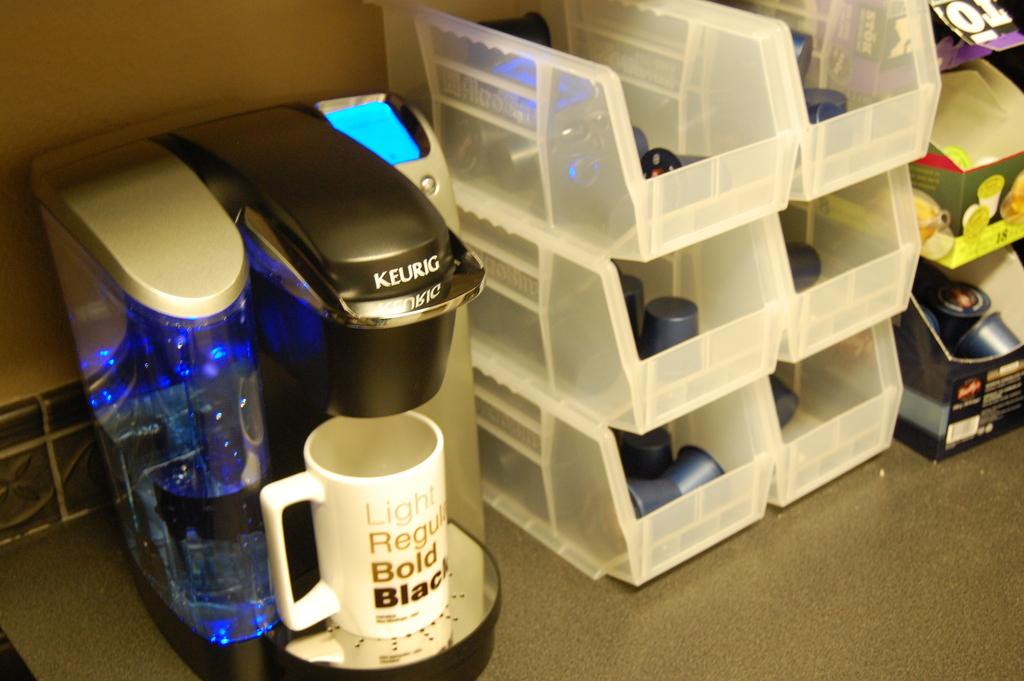What company makes the coffee machine?
Give a very brief answer. Keurig. What brand is the coffee maker?
Your answer should be very brief. Keurig. 